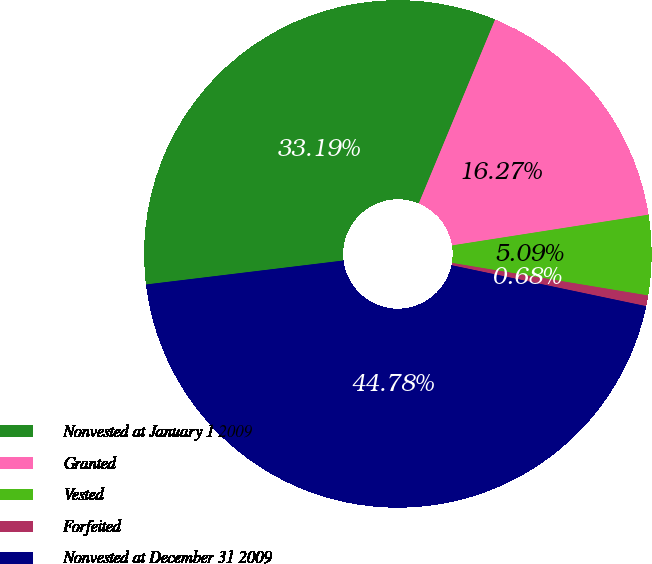Convert chart. <chart><loc_0><loc_0><loc_500><loc_500><pie_chart><fcel>Nonvested at January 1 2009<fcel>Granted<fcel>Vested<fcel>Forfeited<fcel>Nonvested at December 31 2009<nl><fcel>33.19%<fcel>16.27%<fcel>5.09%<fcel>0.68%<fcel>44.78%<nl></chart> 